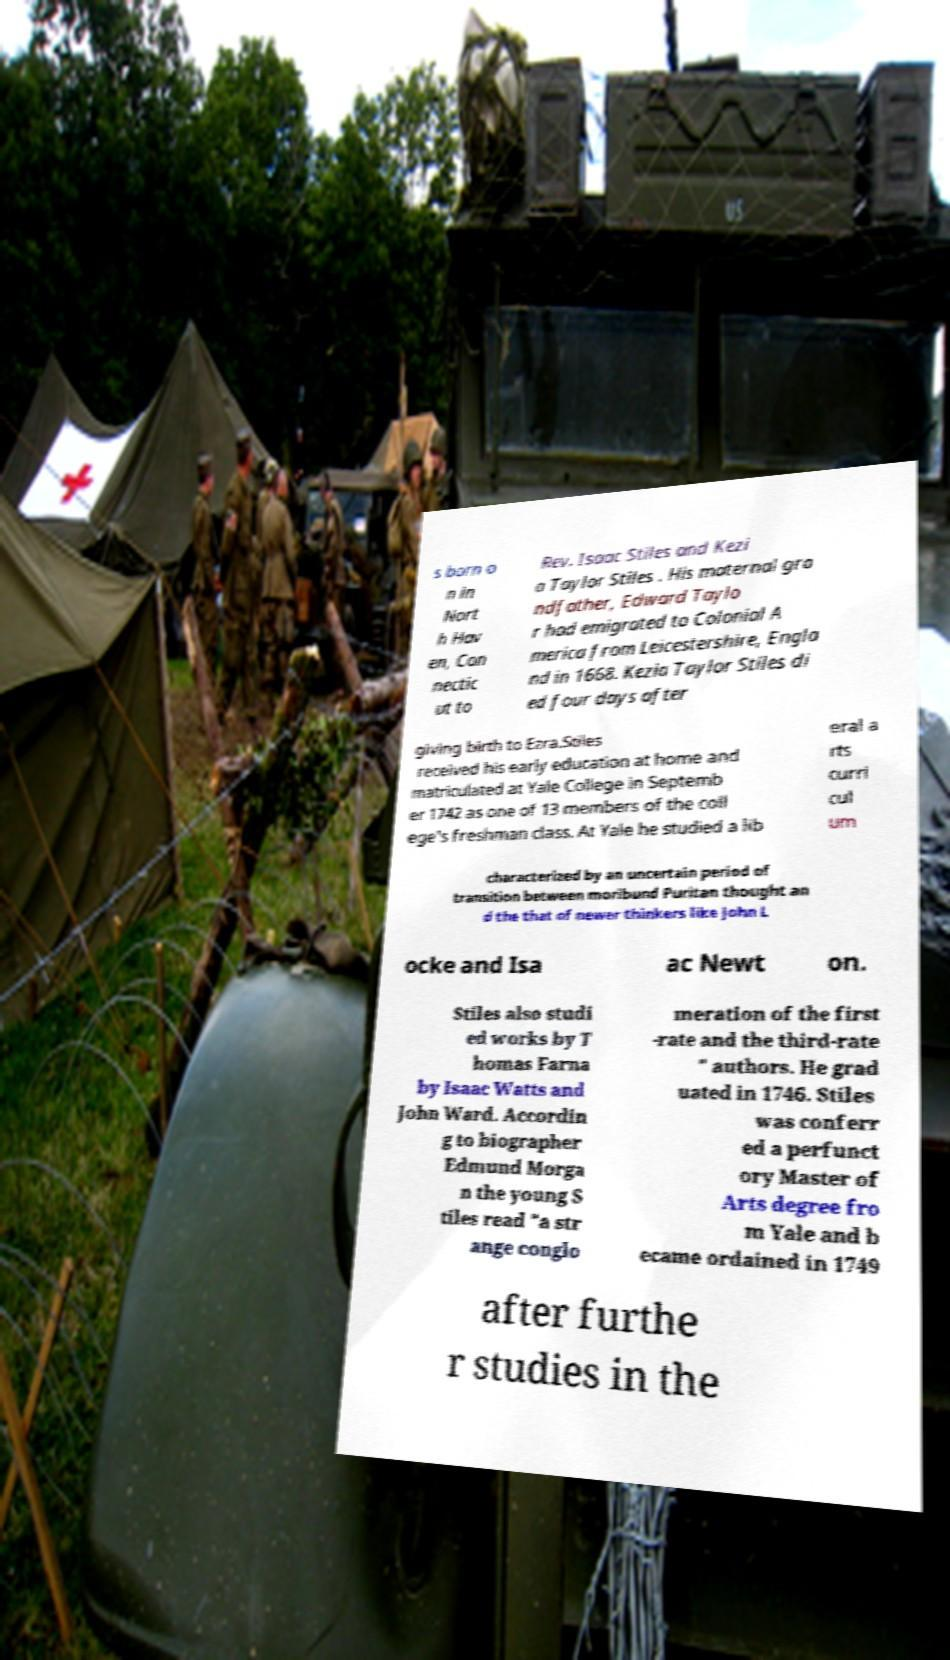Please read and relay the text visible in this image. What does it say? s born o n in Nort h Hav en, Con nectic ut to Rev. Isaac Stiles and Kezi a Taylor Stiles . His maternal gra ndfather, Edward Taylo r had emigrated to Colonial A merica from Leicestershire, Engla nd in 1668. Kezia Taylor Stiles di ed four days after giving birth to Ezra.Stiles received his early education at home and matriculated at Yale College in Septemb er 1742 as one of 13 members of the coll ege's freshman class. At Yale he studied a lib eral a rts curri cul um characterized by an uncertain period of transition between moribund Puritan thought an d the that of newer thinkers like John L ocke and Isa ac Newt on. Stiles also studi ed works by T homas Farna by Isaac Watts and John Ward. Accordin g to biographer Edmund Morga n the young S tiles read "a str ange conglo meration of the first -rate and the third-rate " authors. He grad uated in 1746. Stiles was conferr ed a perfunct ory Master of Arts degree fro m Yale and b ecame ordained in 1749 after furthe r studies in the 